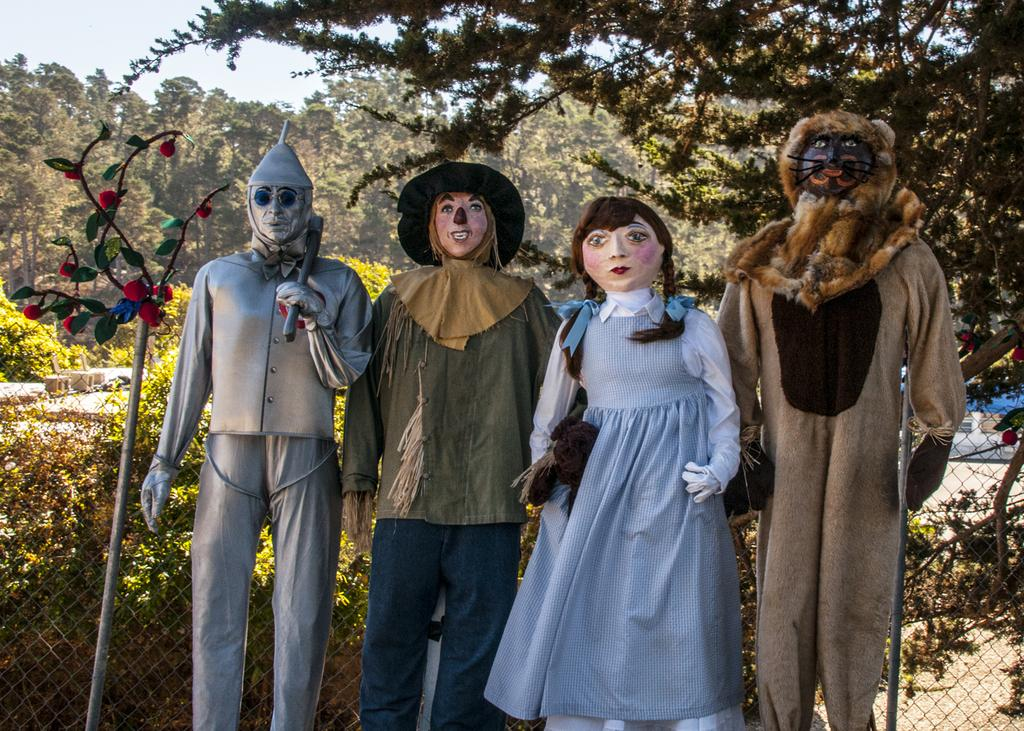What can be found at the bottom of the image? There are statues at the bottom of the image. What type of vegetation is visible in the background of the image? There are trees in the background of the image. What is visible at the top of the image? The sky is visible at the top of the image. Can you compare the size of the statues to the size of an animal in the image? There are no animals present in the image, so it is not possible to make a comparison. What type of beverage is being served in the image? There is no beverage, such as eggnog, present in the image. 